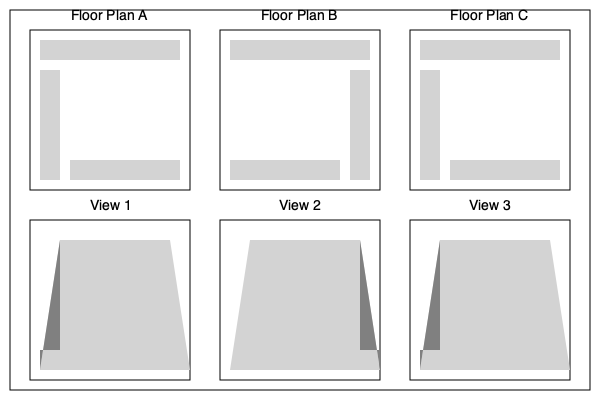Which perspective view (1, 2, or 3) correctly represents the sales booth setup shown in Floor Plan B? To determine the correct perspective view for Floor Plan B, let's analyze the floor plan and compare it to the given perspective views:

1. Floor Plan B shows:
   - A long counter at the top
   - A short counter on the right side
   - A long counter at the bottom, but shorter than the top one

2. Analyzing the perspective views:
   - View 1: Shows a long counter on the left side (which would be the front in perspective)
   - View 2: Shows a long counter on the right side (which would be the front in perspective)
   - View 3: Shows a long counter on the left side (which would be the front in perspective)

3. Matching Floor Plan B to the views:
   - The long counter at the top of Floor Plan B should appear as the longest side in the perspective view
   - The short counter on the right in Floor Plan B should appear on the right side in the perspective view
   - The bottom counter in Floor Plan B should appear shorter than the top counter in the perspective view

4. Conclusion:
   View 2 is the only perspective that matches these criteria. It shows the longest counter on the right (corresponding to the top in Floor Plan B), a shorter counter on the left (corresponding to the bottom in Floor Plan B), and the short side counter on the right (matching the right side in Floor Plan B).
Answer: View 2 